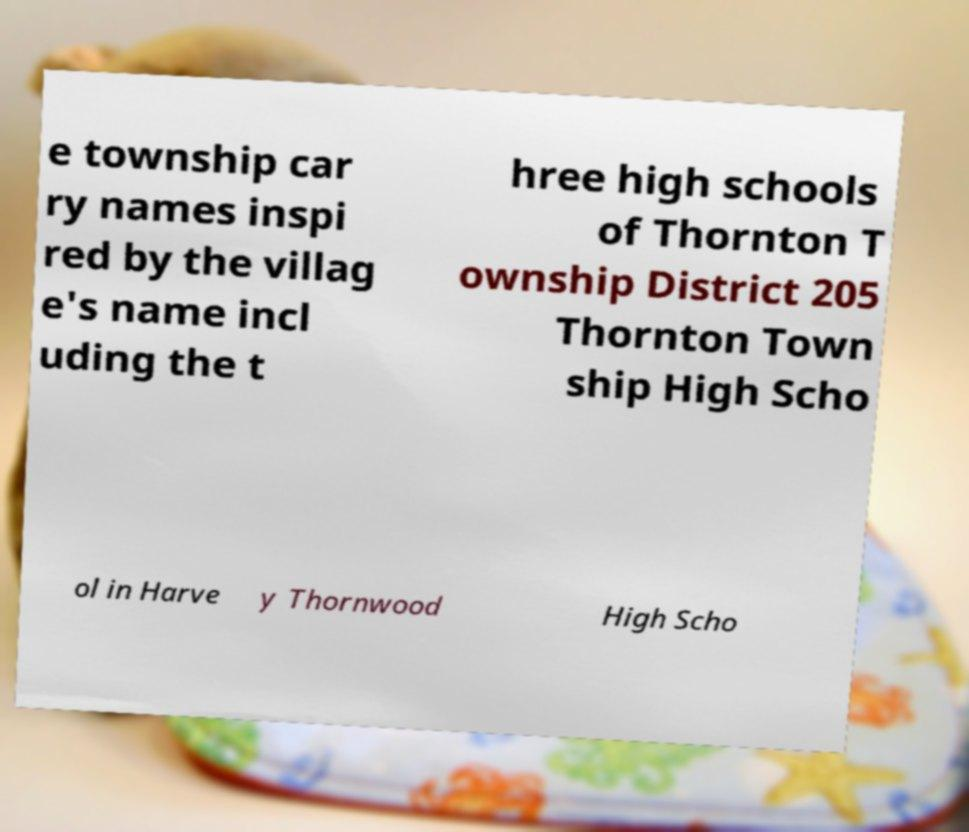There's text embedded in this image that I need extracted. Can you transcribe it verbatim? e township car ry names inspi red by the villag e's name incl uding the t hree high schools of Thornton T ownship District 205 Thornton Town ship High Scho ol in Harve y Thornwood High Scho 